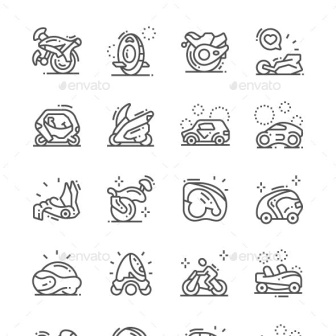Can you provide a detailed analysis of how these icons could be integrated into a mobile app's user interface design? Certainly! These transportation icons can significantly enhance a mobile app's user interface by serving as intuitive visual cues. Each icon, given its distinct and clear representation, can act as a button or a category marker within the app. For instance, in a travel or navigation app, the motorcycle icon could lead users to motorcycle rental services, while the car icon could open a menu for car hire options. The jet ski icon might be perfect for booking water sports activities. The timeless black and white palette ensures that these icons blend seamlessly with various app themes, whether it's a dark mode or a colorful interface. Their minimalist design minimizes visual clutter, keeping the UI sleek and user-friendly. Furthermore, the dynamic elements like dots and lines suggesting movement could be animated to enhance user interaction, such as spinning wheels or moving dots, providing an engaging user experience. 